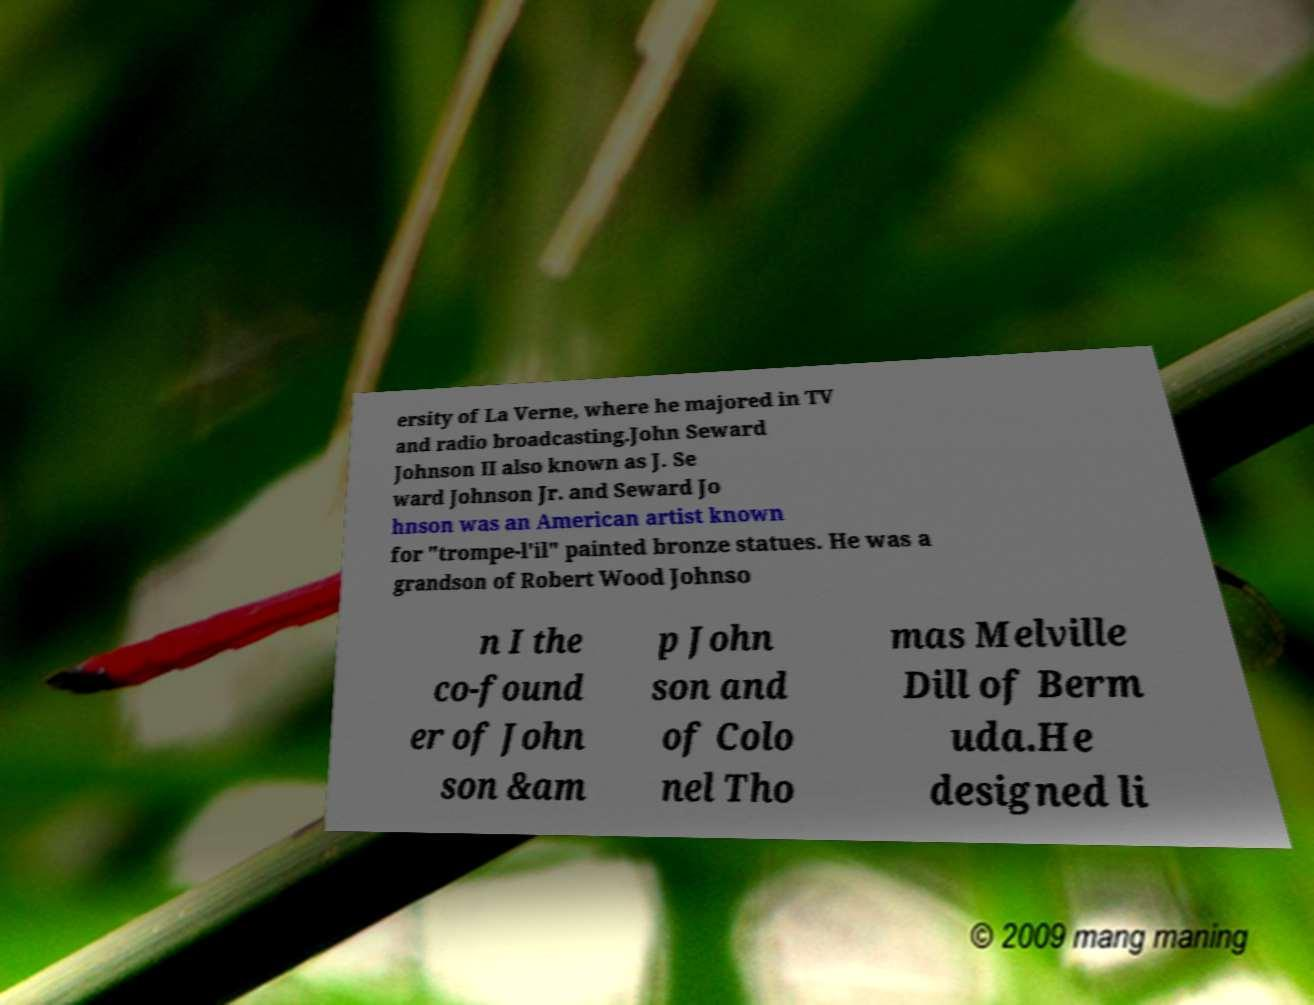I need the written content from this picture converted into text. Can you do that? ersity of La Verne, where he majored in TV and radio broadcasting.John Seward Johnson II also known as J. Se ward Johnson Jr. and Seward Jo hnson was an American artist known for "trompe-l'il" painted bronze statues. He was a grandson of Robert Wood Johnso n I the co-found er of John son &am p John son and of Colo nel Tho mas Melville Dill of Berm uda.He designed li 